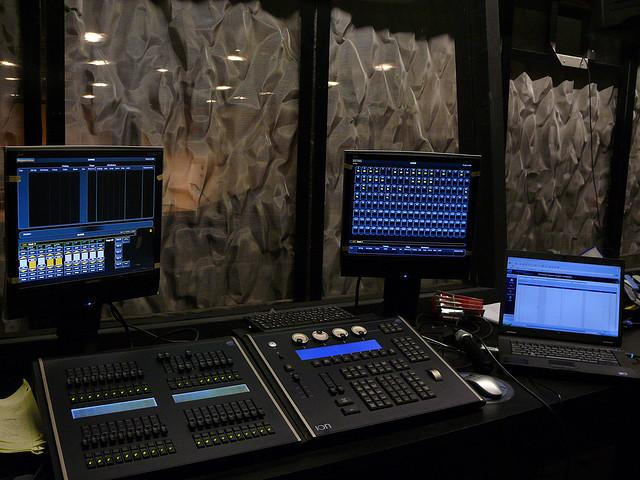The sliders on the equipment on the desk is used to adjust what? sound 